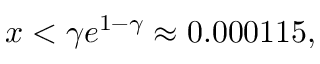<formula> <loc_0><loc_0><loc_500><loc_500>x < \gamma e ^ { 1 - \gamma } \approx 0 . 0 0 0 1 1 5 ,</formula> 